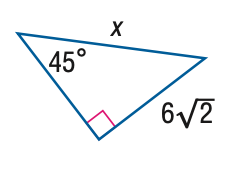Answer the mathemtical geometry problem and directly provide the correct option letter.
Question: Find x.
Choices: A: 6 B: 4 \sqrt { 6 } C: 12 D: 12 \sqrt { 2 } C 